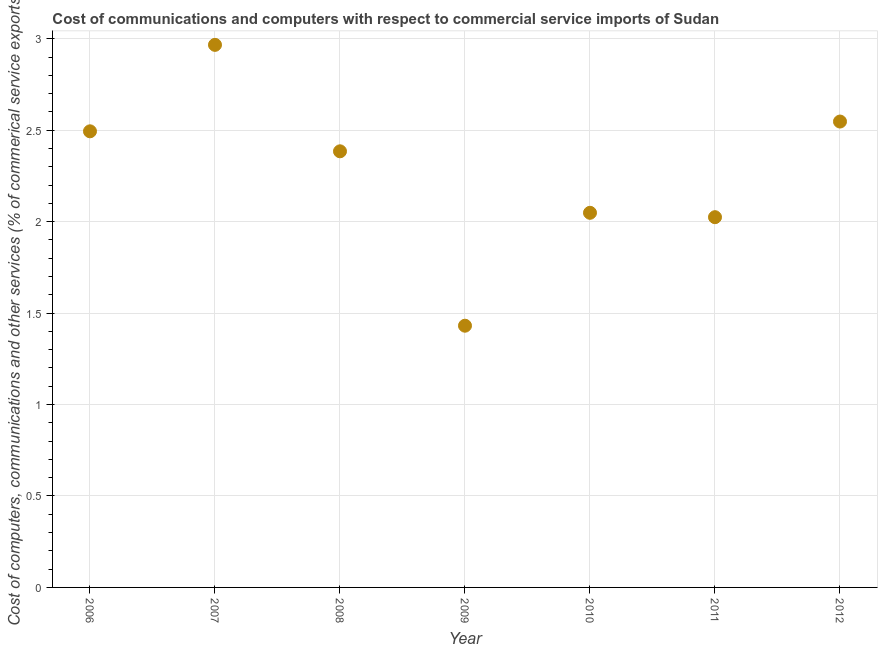What is the  computer and other services in 2012?
Offer a terse response. 2.55. Across all years, what is the maximum cost of communications?
Your response must be concise. 2.97. Across all years, what is the minimum  computer and other services?
Offer a terse response. 1.43. What is the sum of the cost of communications?
Your answer should be compact. 15.89. What is the difference between the cost of communications in 2007 and 2011?
Your response must be concise. 0.94. What is the average  computer and other services per year?
Ensure brevity in your answer.  2.27. What is the median  computer and other services?
Offer a very short reply. 2.38. Do a majority of the years between 2012 and 2009 (inclusive) have cost of communications greater than 1.7 %?
Your response must be concise. Yes. What is the ratio of the cost of communications in 2008 to that in 2009?
Make the answer very short. 1.67. Is the  computer and other services in 2009 less than that in 2011?
Your answer should be very brief. Yes. What is the difference between the highest and the second highest  computer and other services?
Ensure brevity in your answer.  0.42. What is the difference between the highest and the lowest cost of communications?
Offer a terse response. 1.54. Does the cost of communications monotonically increase over the years?
Make the answer very short. No. How many years are there in the graph?
Provide a short and direct response. 7. What is the difference between two consecutive major ticks on the Y-axis?
Offer a very short reply. 0.5. Are the values on the major ticks of Y-axis written in scientific E-notation?
Your answer should be very brief. No. Does the graph contain grids?
Provide a succinct answer. Yes. What is the title of the graph?
Offer a very short reply. Cost of communications and computers with respect to commercial service imports of Sudan. What is the label or title of the X-axis?
Make the answer very short. Year. What is the label or title of the Y-axis?
Keep it short and to the point. Cost of computers, communications and other services (% of commerical service exports). What is the Cost of computers, communications and other services (% of commerical service exports) in 2006?
Ensure brevity in your answer.  2.49. What is the Cost of computers, communications and other services (% of commerical service exports) in 2007?
Offer a terse response. 2.97. What is the Cost of computers, communications and other services (% of commerical service exports) in 2008?
Provide a succinct answer. 2.38. What is the Cost of computers, communications and other services (% of commerical service exports) in 2009?
Provide a short and direct response. 1.43. What is the Cost of computers, communications and other services (% of commerical service exports) in 2010?
Give a very brief answer. 2.05. What is the Cost of computers, communications and other services (% of commerical service exports) in 2011?
Your answer should be compact. 2.02. What is the Cost of computers, communications and other services (% of commerical service exports) in 2012?
Provide a succinct answer. 2.55. What is the difference between the Cost of computers, communications and other services (% of commerical service exports) in 2006 and 2007?
Your answer should be compact. -0.47. What is the difference between the Cost of computers, communications and other services (% of commerical service exports) in 2006 and 2008?
Give a very brief answer. 0.11. What is the difference between the Cost of computers, communications and other services (% of commerical service exports) in 2006 and 2009?
Make the answer very short. 1.06. What is the difference between the Cost of computers, communications and other services (% of commerical service exports) in 2006 and 2010?
Offer a terse response. 0.45. What is the difference between the Cost of computers, communications and other services (% of commerical service exports) in 2006 and 2011?
Give a very brief answer. 0.47. What is the difference between the Cost of computers, communications and other services (% of commerical service exports) in 2006 and 2012?
Ensure brevity in your answer.  -0.05. What is the difference between the Cost of computers, communications and other services (% of commerical service exports) in 2007 and 2008?
Make the answer very short. 0.58. What is the difference between the Cost of computers, communications and other services (% of commerical service exports) in 2007 and 2009?
Offer a very short reply. 1.54. What is the difference between the Cost of computers, communications and other services (% of commerical service exports) in 2007 and 2010?
Give a very brief answer. 0.92. What is the difference between the Cost of computers, communications and other services (% of commerical service exports) in 2007 and 2011?
Ensure brevity in your answer.  0.94. What is the difference between the Cost of computers, communications and other services (% of commerical service exports) in 2007 and 2012?
Your response must be concise. 0.42. What is the difference between the Cost of computers, communications and other services (% of commerical service exports) in 2008 and 2009?
Offer a very short reply. 0.95. What is the difference between the Cost of computers, communications and other services (% of commerical service exports) in 2008 and 2010?
Your response must be concise. 0.34. What is the difference between the Cost of computers, communications and other services (% of commerical service exports) in 2008 and 2011?
Make the answer very short. 0.36. What is the difference between the Cost of computers, communications and other services (% of commerical service exports) in 2008 and 2012?
Offer a very short reply. -0.16. What is the difference between the Cost of computers, communications and other services (% of commerical service exports) in 2009 and 2010?
Give a very brief answer. -0.62. What is the difference between the Cost of computers, communications and other services (% of commerical service exports) in 2009 and 2011?
Keep it short and to the point. -0.59. What is the difference between the Cost of computers, communications and other services (% of commerical service exports) in 2009 and 2012?
Your answer should be compact. -1.12. What is the difference between the Cost of computers, communications and other services (% of commerical service exports) in 2010 and 2011?
Your answer should be very brief. 0.02. What is the difference between the Cost of computers, communications and other services (% of commerical service exports) in 2010 and 2012?
Offer a terse response. -0.5. What is the difference between the Cost of computers, communications and other services (% of commerical service exports) in 2011 and 2012?
Offer a terse response. -0.52. What is the ratio of the Cost of computers, communications and other services (% of commerical service exports) in 2006 to that in 2007?
Your response must be concise. 0.84. What is the ratio of the Cost of computers, communications and other services (% of commerical service exports) in 2006 to that in 2008?
Make the answer very short. 1.05. What is the ratio of the Cost of computers, communications and other services (% of commerical service exports) in 2006 to that in 2009?
Offer a terse response. 1.74. What is the ratio of the Cost of computers, communications and other services (% of commerical service exports) in 2006 to that in 2010?
Provide a short and direct response. 1.22. What is the ratio of the Cost of computers, communications and other services (% of commerical service exports) in 2006 to that in 2011?
Provide a short and direct response. 1.23. What is the ratio of the Cost of computers, communications and other services (% of commerical service exports) in 2007 to that in 2008?
Give a very brief answer. 1.24. What is the ratio of the Cost of computers, communications and other services (% of commerical service exports) in 2007 to that in 2009?
Make the answer very short. 2.07. What is the ratio of the Cost of computers, communications and other services (% of commerical service exports) in 2007 to that in 2010?
Ensure brevity in your answer.  1.45. What is the ratio of the Cost of computers, communications and other services (% of commerical service exports) in 2007 to that in 2011?
Give a very brief answer. 1.47. What is the ratio of the Cost of computers, communications and other services (% of commerical service exports) in 2007 to that in 2012?
Offer a very short reply. 1.17. What is the ratio of the Cost of computers, communications and other services (% of commerical service exports) in 2008 to that in 2009?
Give a very brief answer. 1.67. What is the ratio of the Cost of computers, communications and other services (% of commerical service exports) in 2008 to that in 2010?
Your answer should be very brief. 1.16. What is the ratio of the Cost of computers, communications and other services (% of commerical service exports) in 2008 to that in 2011?
Your response must be concise. 1.18. What is the ratio of the Cost of computers, communications and other services (% of commerical service exports) in 2008 to that in 2012?
Provide a succinct answer. 0.94. What is the ratio of the Cost of computers, communications and other services (% of commerical service exports) in 2009 to that in 2010?
Keep it short and to the point. 0.7. What is the ratio of the Cost of computers, communications and other services (% of commerical service exports) in 2009 to that in 2011?
Provide a short and direct response. 0.71. What is the ratio of the Cost of computers, communications and other services (% of commerical service exports) in 2009 to that in 2012?
Provide a succinct answer. 0.56. What is the ratio of the Cost of computers, communications and other services (% of commerical service exports) in 2010 to that in 2012?
Give a very brief answer. 0.8. What is the ratio of the Cost of computers, communications and other services (% of commerical service exports) in 2011 to that in 2012?
Offer a terse response. 0.8. 